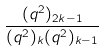<formula> <loc_0><loc_0><loc_500><loc_500>\frac { ( q ^ { 2 } ) _ { 2 k - 1 } } { ( q ^ { 2 } ) _ { k } ( q ^ { 2 } ) _ { k - 1 } }</formula> 